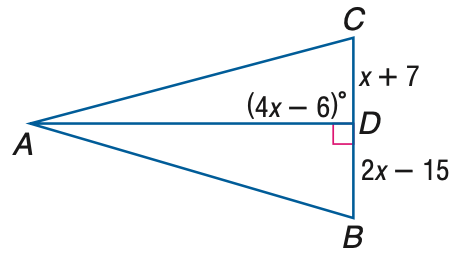Answer the mathemtical geometry problem and directly provide the correct option letter.
Question: Find x if A D is an altitude of \triangle A B C.
Choices: A: 12 B: 18 C: 22 D: 24 D 